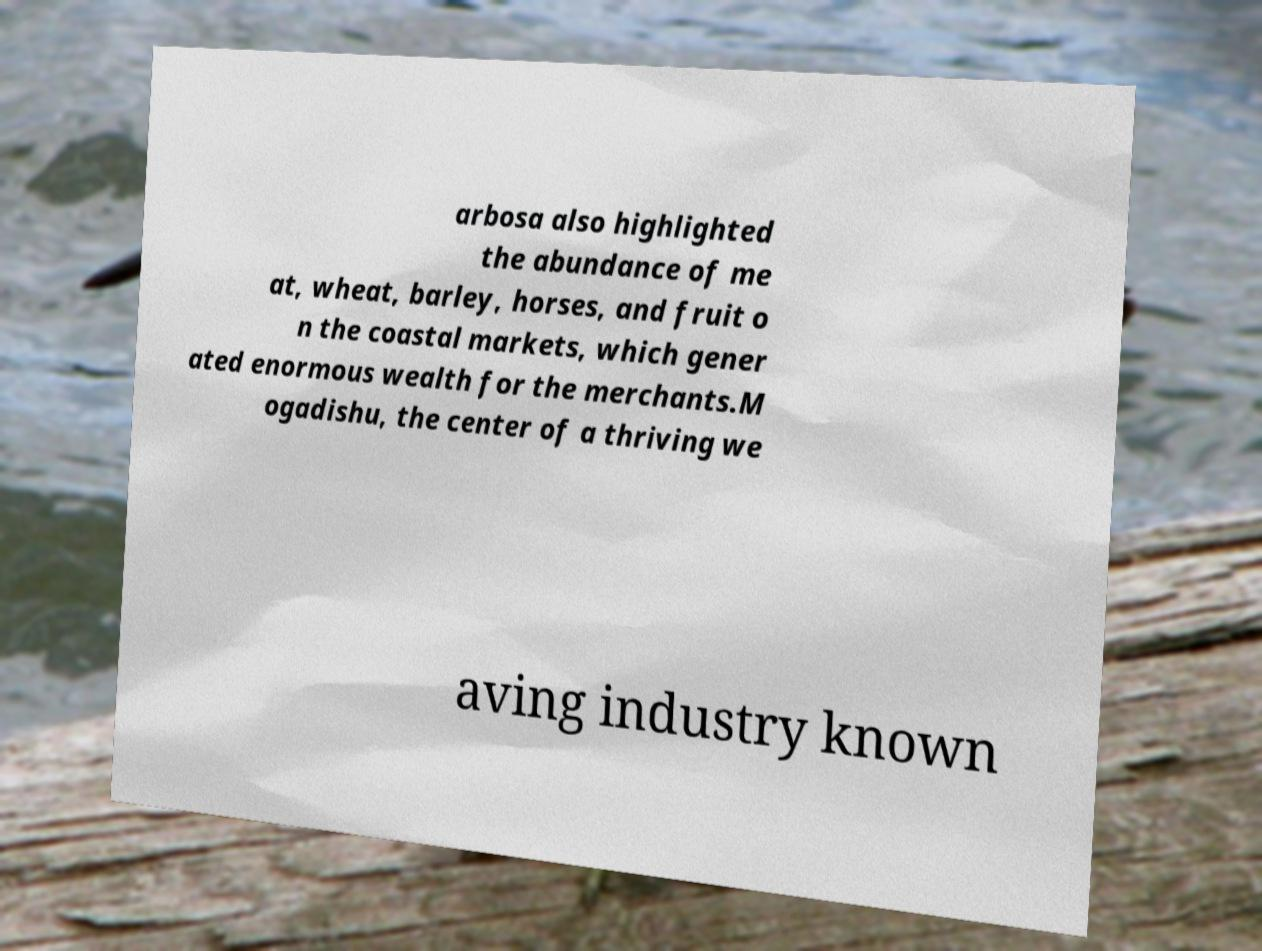What messages or text are displayed in this image? I need them in a readable, typed format. arbosa also highlighted the abundance of me at, wheat, barley, horses, and fruit o n the coastal markets, which gener ated enormous wealth for the merchants.M ogadishu, the center of a thriving we aving industry known 